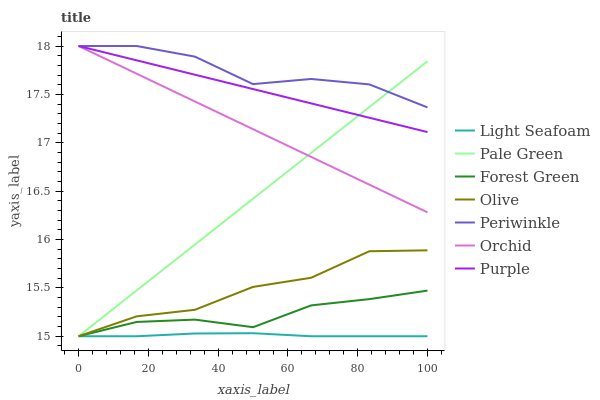Does Forest Green have the minimum area under the curve?
Answer yes or no. No. Does Forest Green have the maximum area under the curve?
Answer yes or no. No. Is Forest Green the smoothest?
Answer yes or no. No. Is Forest Green the roughest?
Answer yes or no. No. Does Periwinkle have the lowest value?
Answer yes or no. No. Does Forest Green have the highest value?
Answer yes or no. No. Is Olive less than Orchid?
Answer yes or no. Yes. Is Orchid greater than Olive?
Answer yes or no. Yes. Does Olive intersect Orchid?
Answer yes or no. No. 